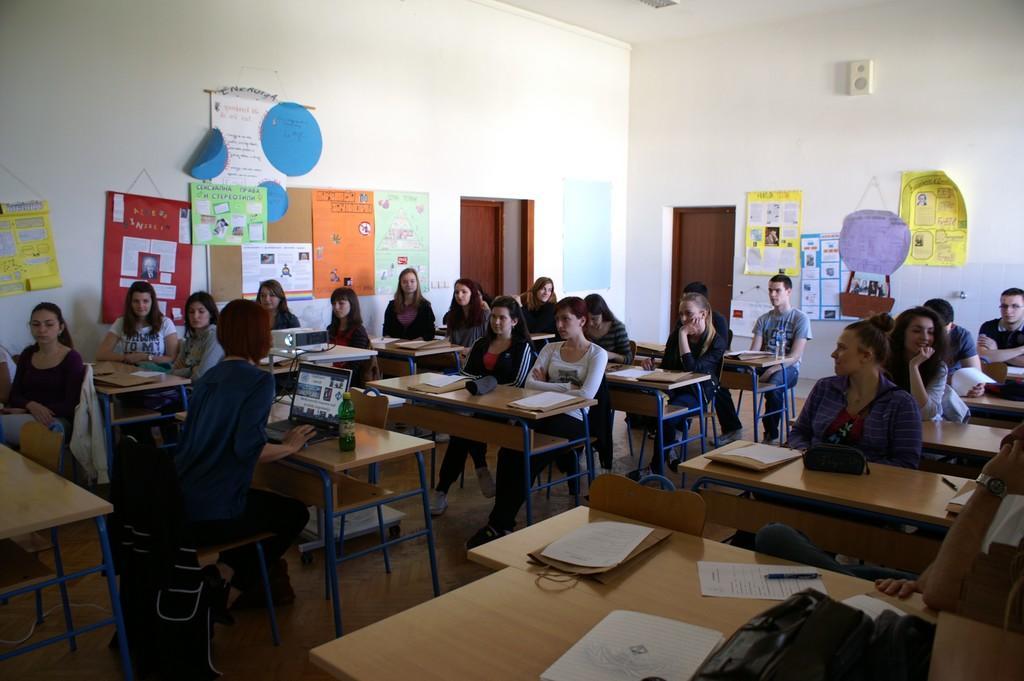Could you give a brief overview of what you see in this image? Here we can see group of people sitting on chairs with table in front of them and here is a lady sitting with a laptop and a bottle in front of her and on the walls we can see charts pasted and beside them we can see a door 